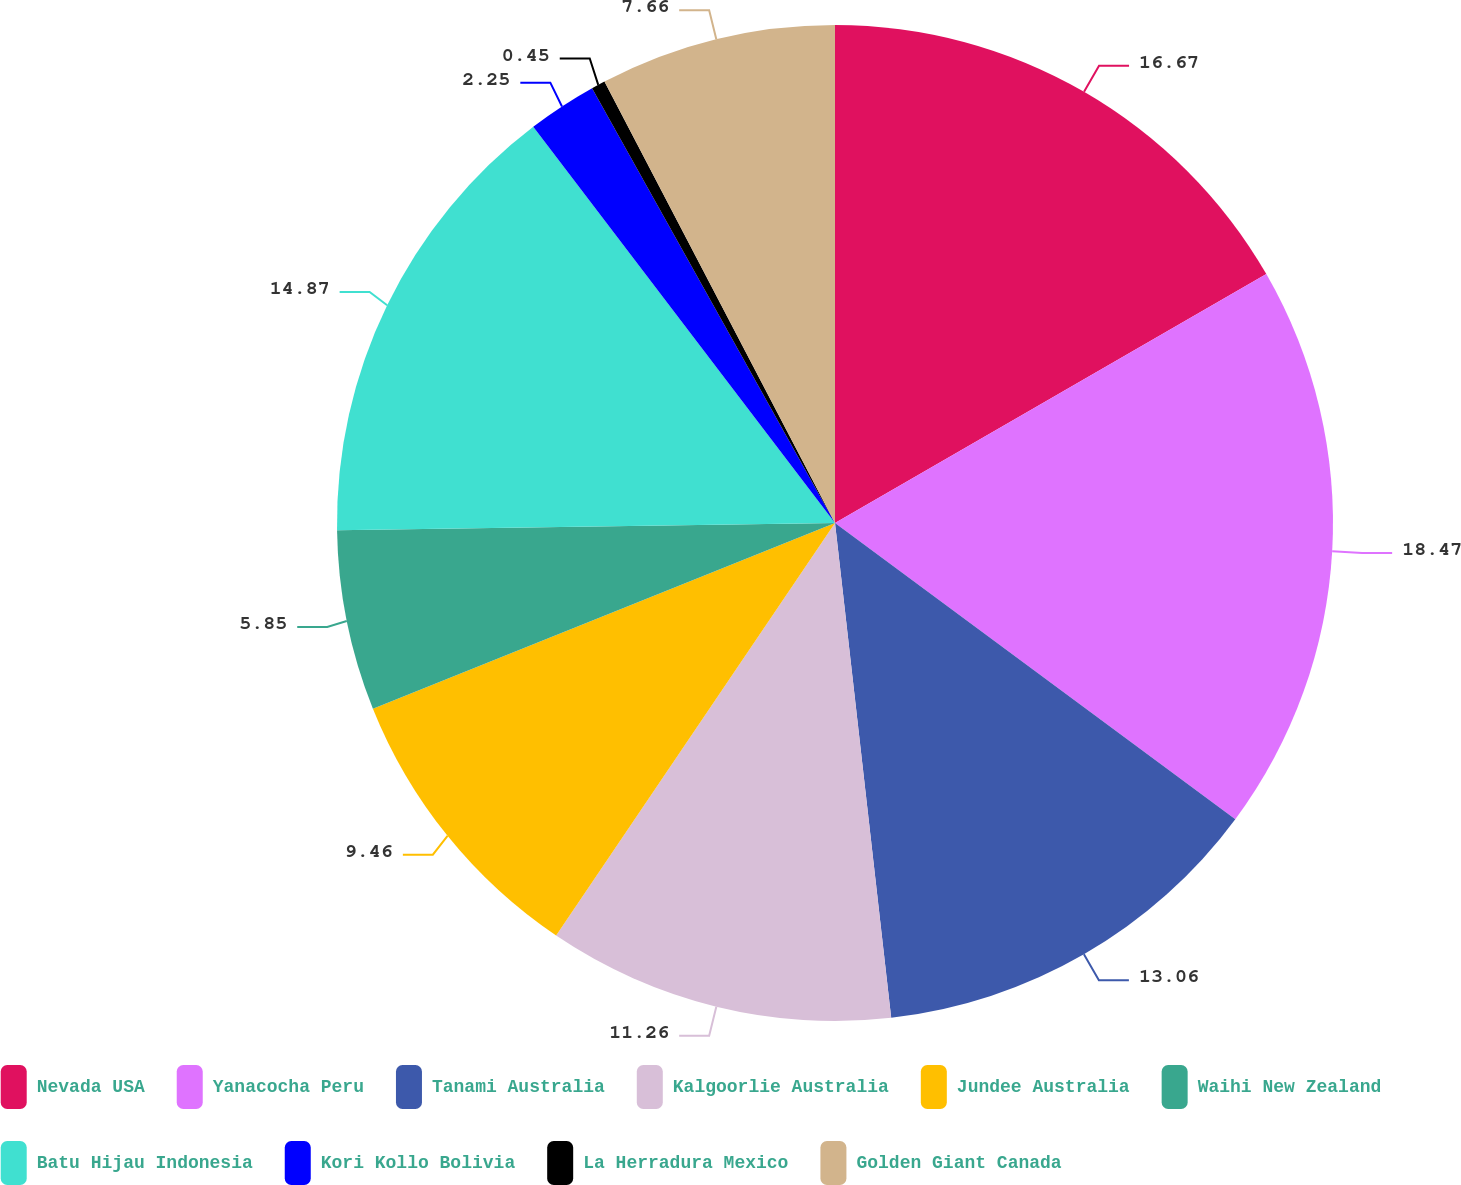<chart> <loc_0><loc_0><loc_500><loc_500><pie_chart><fcel>Nevada USA<fcel>Yanacocha Peru<fcel>Tanami Australia<fcel>Kalgoorlie Australia<fcel>Jundee Australia<fcel>Waihi New Zealand<fcel>Batu Hijau Indonesia<fcel>Kori Kollo Bolivia<fcel>La Herradura Mexico<fcel>Golden Giant Canada<nl><fcel>16.67%<fcel>18.47%<fcel>13.06%<fcel>11.26%<fcel>9.46%<fcel>5.85%<fcel>14.87%<fcel>2.25%<fcel>0.45%<fcel>7.66%<nl></chart> 